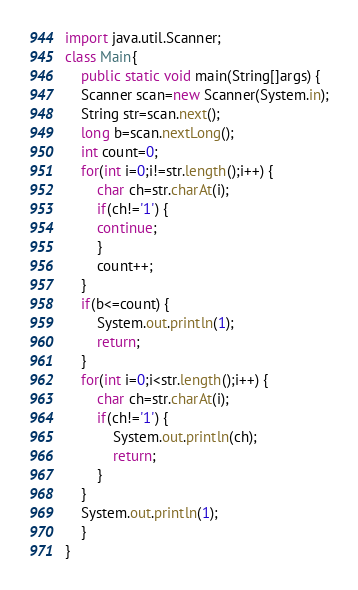<code> <loc_0><loc_0><loc_500><loc_500><_Java_>import java.util.Scanner;
class Main{
	public static void main(String[]args) {
	Scanner scan=new Scanner(System.in);
	String str=scan.next();
	long b=scan.nextLong();
	int count=0;
	for(int i=0;i!=str.length();i++) {
		char ch=str.charAt(i);
		if(ch!='1') {
		continue;
		}
		count++;
	}
	if(b<=count) {
		System.out.println(1);
		return;
	}
	for(int i=0;i<str.length();i++) {
		char ch=str.charAt(i);
		if(ch!='1') {
			System.out.println(ch);
			return;
		}
	}
	System.out.println(1);
	}
}</code> 